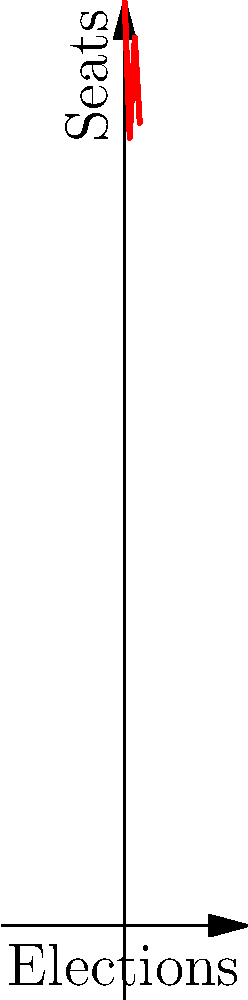Based on the graph showing Liberal Party seat counts in recent Canadian elections, calculate the vector representing the change in seats from 2015 to 2023. Express your answer as an ordered pair $(x, y)$, where $x$ represents the number of elections passed and $y$ represents the change in seats. To find the vector representing the change from 2015 to 2023:

1. Identify the starting point (2015 election): $(0, 184)$
2. Identify the ending point (2023 election): $(3, 160)$
3. Calculate the change in $x$ (elections passed):
   $3 - 0 = 3$
4. Calculate the change in $y$ (seats):
   $160 - 184 = -24$
5. Express the change as a vector: $(3, -24)$

This vector shows that over 3 elections, the Liberal Party lost 24 seats.
Answer: $(3, -24)$ 